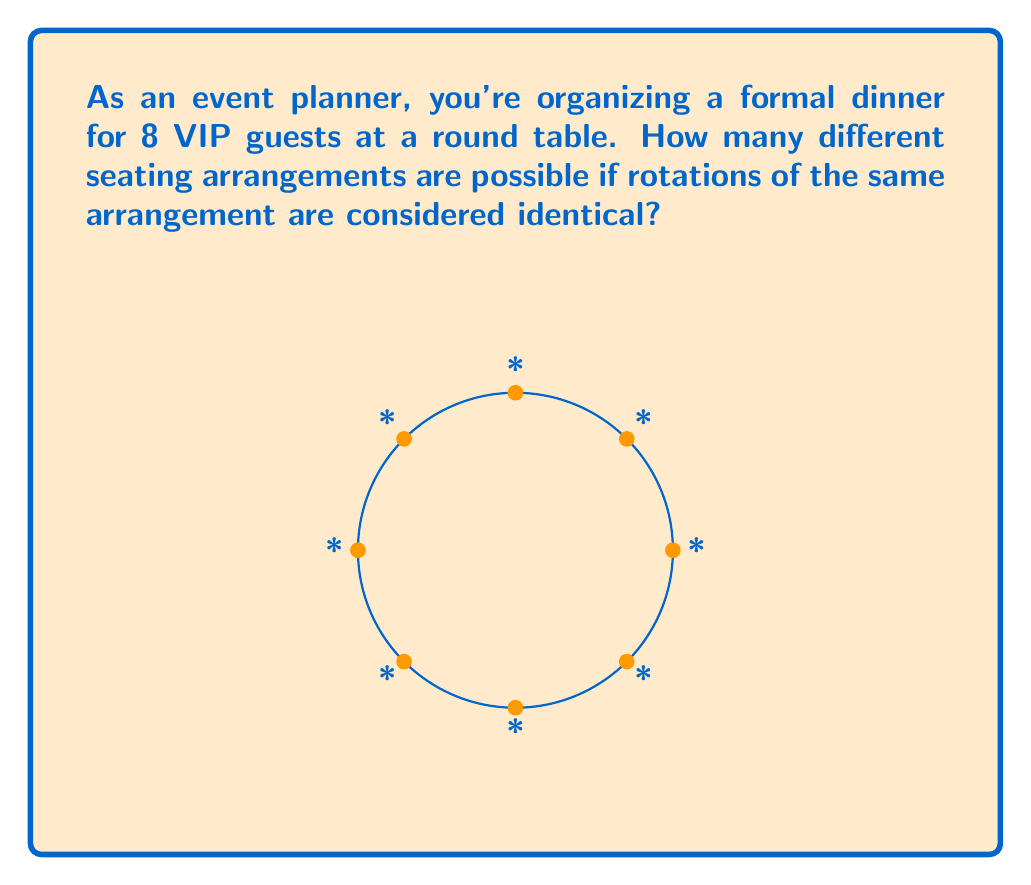Teach me how to tackle this problem. Let's approach this step-by-step:

1) First, we need to understand that in a circular arrangement, rotations are considered the same. This means we can fix the position of one person and arrange the rest.

2) We have 8 people in total. Let's fix the position of the first person.

3) Now, we need to arrange the remaining 7 people in the other 7 seats.

4) This becomes a straightforward permutation problem. We're arranging 7 people in 7 positions.

5) The number of permutations of n distinct objects is given by n!

6) In this case, we're permuting 7 people, so the number of arrangements is 7!

7) Let's calculate 7!:
   $$7! = 7 \times 6 \times 5 \times 4 \times 3 \times 2 \times 1 = 5040$$

Therefore, there are 5040 different seating arrangements possible.
Answer: 5040 